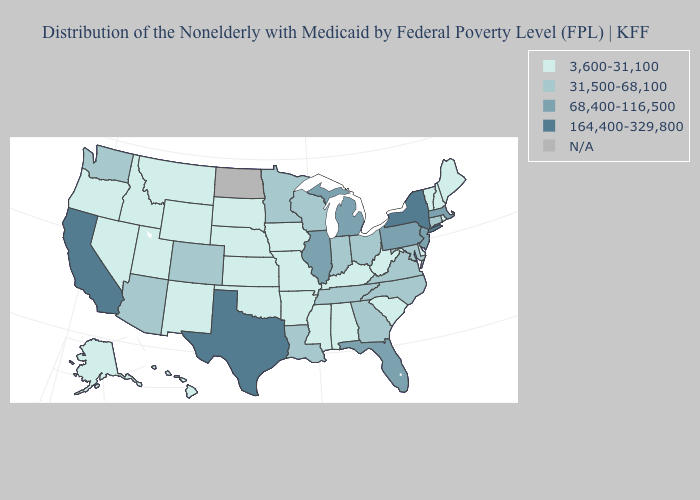Among the states that border Vermont , which have the lowest value?
Be succinct. New Hampshire. Which states have the highest value in the USA?
Keep it brief. California, New York, Texas. Name the states that have a value in the range 68,400-116,500?
Give a very brief answer. Florida, Illinois, Massachusetts, Michigan, New Jersey, Pennsylvania. What is the value of Kentucky?
Give a very brief answer. 3,600-31,100. What is the lowest value in the West?
Be succinct. 3,600-31,100. Which states have the lowest value in the USA?
Short answer required. Alabama, Alaska, Arkansas, Delaware, Hawaii, Idaho, Iowa, Kansas, Kentucky, Maine, Mississippi, Missouri, Montana, Nebraska, Nevada, New Hampshire, New Mexico, Oklahoma, Oregon, Rhode Island, South Carolina, South Dakota, Utah, Vermont, West Virginia, Wyoming. Name the states that have a value in the range 164,400-329,800?
Concise answer only. California, New York, Texas. What is the lowest value in the MidWest?
Quick response, please. 3,600-31,100. Name the states that have a value in the range 31,500-68,100?
Concise answer only. Arizona, Colorado, Connecticut, Georgia, Indiana, Louisiana, Maryland, Minnesota, North Carolina, Ohio, Tennessee, Virginia, Washington, Wisconsin. Which states have the lowest value in the Northeast?
Concise answer only. Maine, New Hampshire, Rhode Island, Vermont. What is the value of North Dakota?
Be succinct. N/A. Name the states that have a value in the range 164,400-329,800?
Concise answer only. California, New York, Texas. What is the highest value in the MidWest ?
Write a very short answer. 68,400-116,500. What is the highest value in the USA?
Answer briefly. 164,400-329,800. Which states have the lowest value in the South?
Answer briefly. Alabama, Arkansas, Delaware, Kentucky, Mississippi, Oklahoma, South Carolina, West Virginia. 